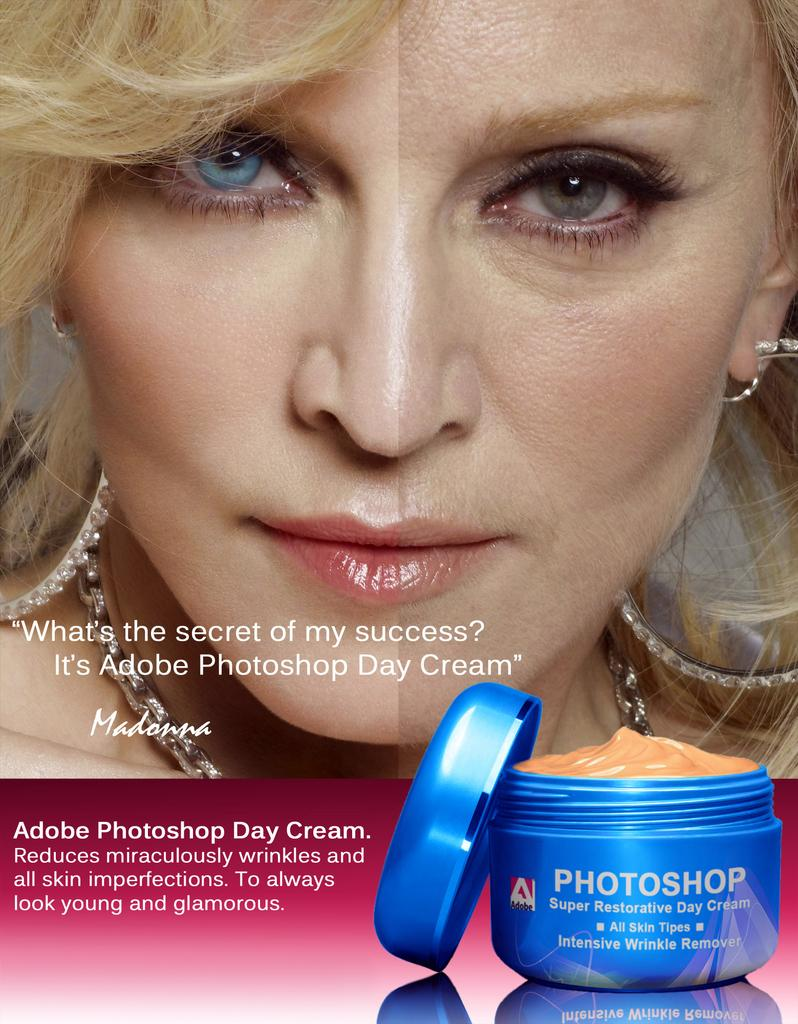<image>
Describe the image concisely. A poster with a before and after face on a woman advertising photoshop day cream. 